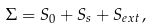Convert formula to latex. <formula><loc_0><loc_0><loc_500><loc_500>\Sigma = S _ { 0 } + S _ { s } + S _ { e x t } \, ,</formula> 